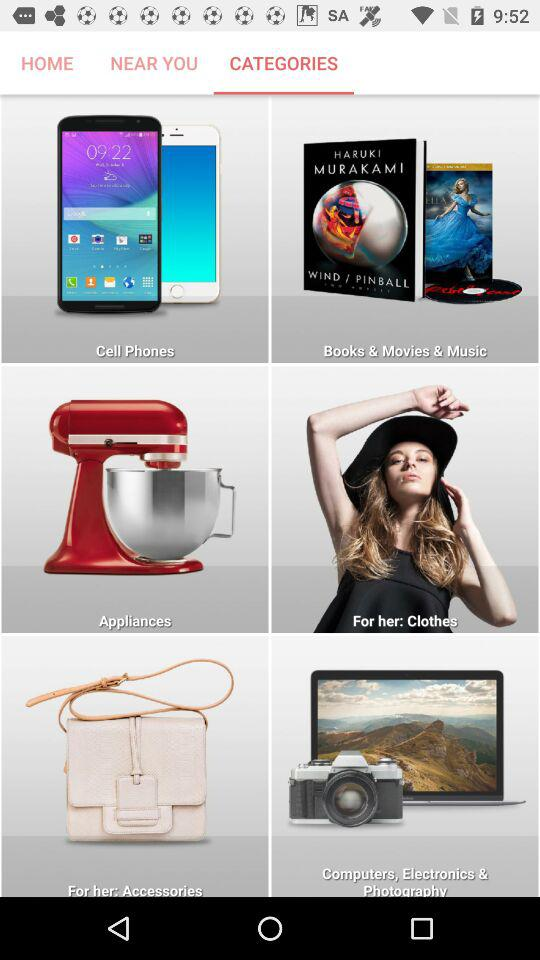Which tab is selected? The selected tab is "CATEGORIES". 